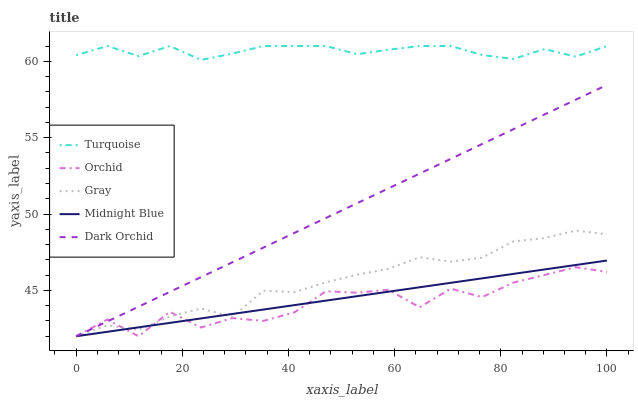Does Orchid have the minimum area under the curve?
Answer yes or no. Yes. Does Turquoise have the maximum area under the curve?
Answer yes or no. Yes. Does Midnight Blue have the minimum area under the curve?
Answer yes or no. No. Does Midnight Blue have the maximum area under the curve?
Answer yes or no. No. Is Midnight Blue the smoothest?
Answer yes or no. Yes. Is Orchid the roughest?
Answer yes or no. Yes. Is Turquoise the smoothest?
Answer yes or no. No. Is Turquoise the roughest?
Answer yes or no. No. Does Gray have the lowest value?
Answer yes or no. Yes. Does Turquoise have the lowest value?
Answer yes or no. No. Does Turquoise have the highest value?
Answer yes or no. Yes. Does Midnight Blue have the highest value?
Answer yes or no. No. Is Dark Orchid less than Turquoise?
Answer yes or no. Yes. Is Turquoise greater than Dark Orchid?
Answer yes or no. Yes. Does Orchid intersect Midnight Blue?
Answer yes or no. Yes. Is Orchid less than Midnight Blue?
Answer yes or no. No. Is Orchid greater than Midnight Blue?
Answer yes or no. No. Does Dark Orchid intersect Turquoise?
Answer yes or no. No. 